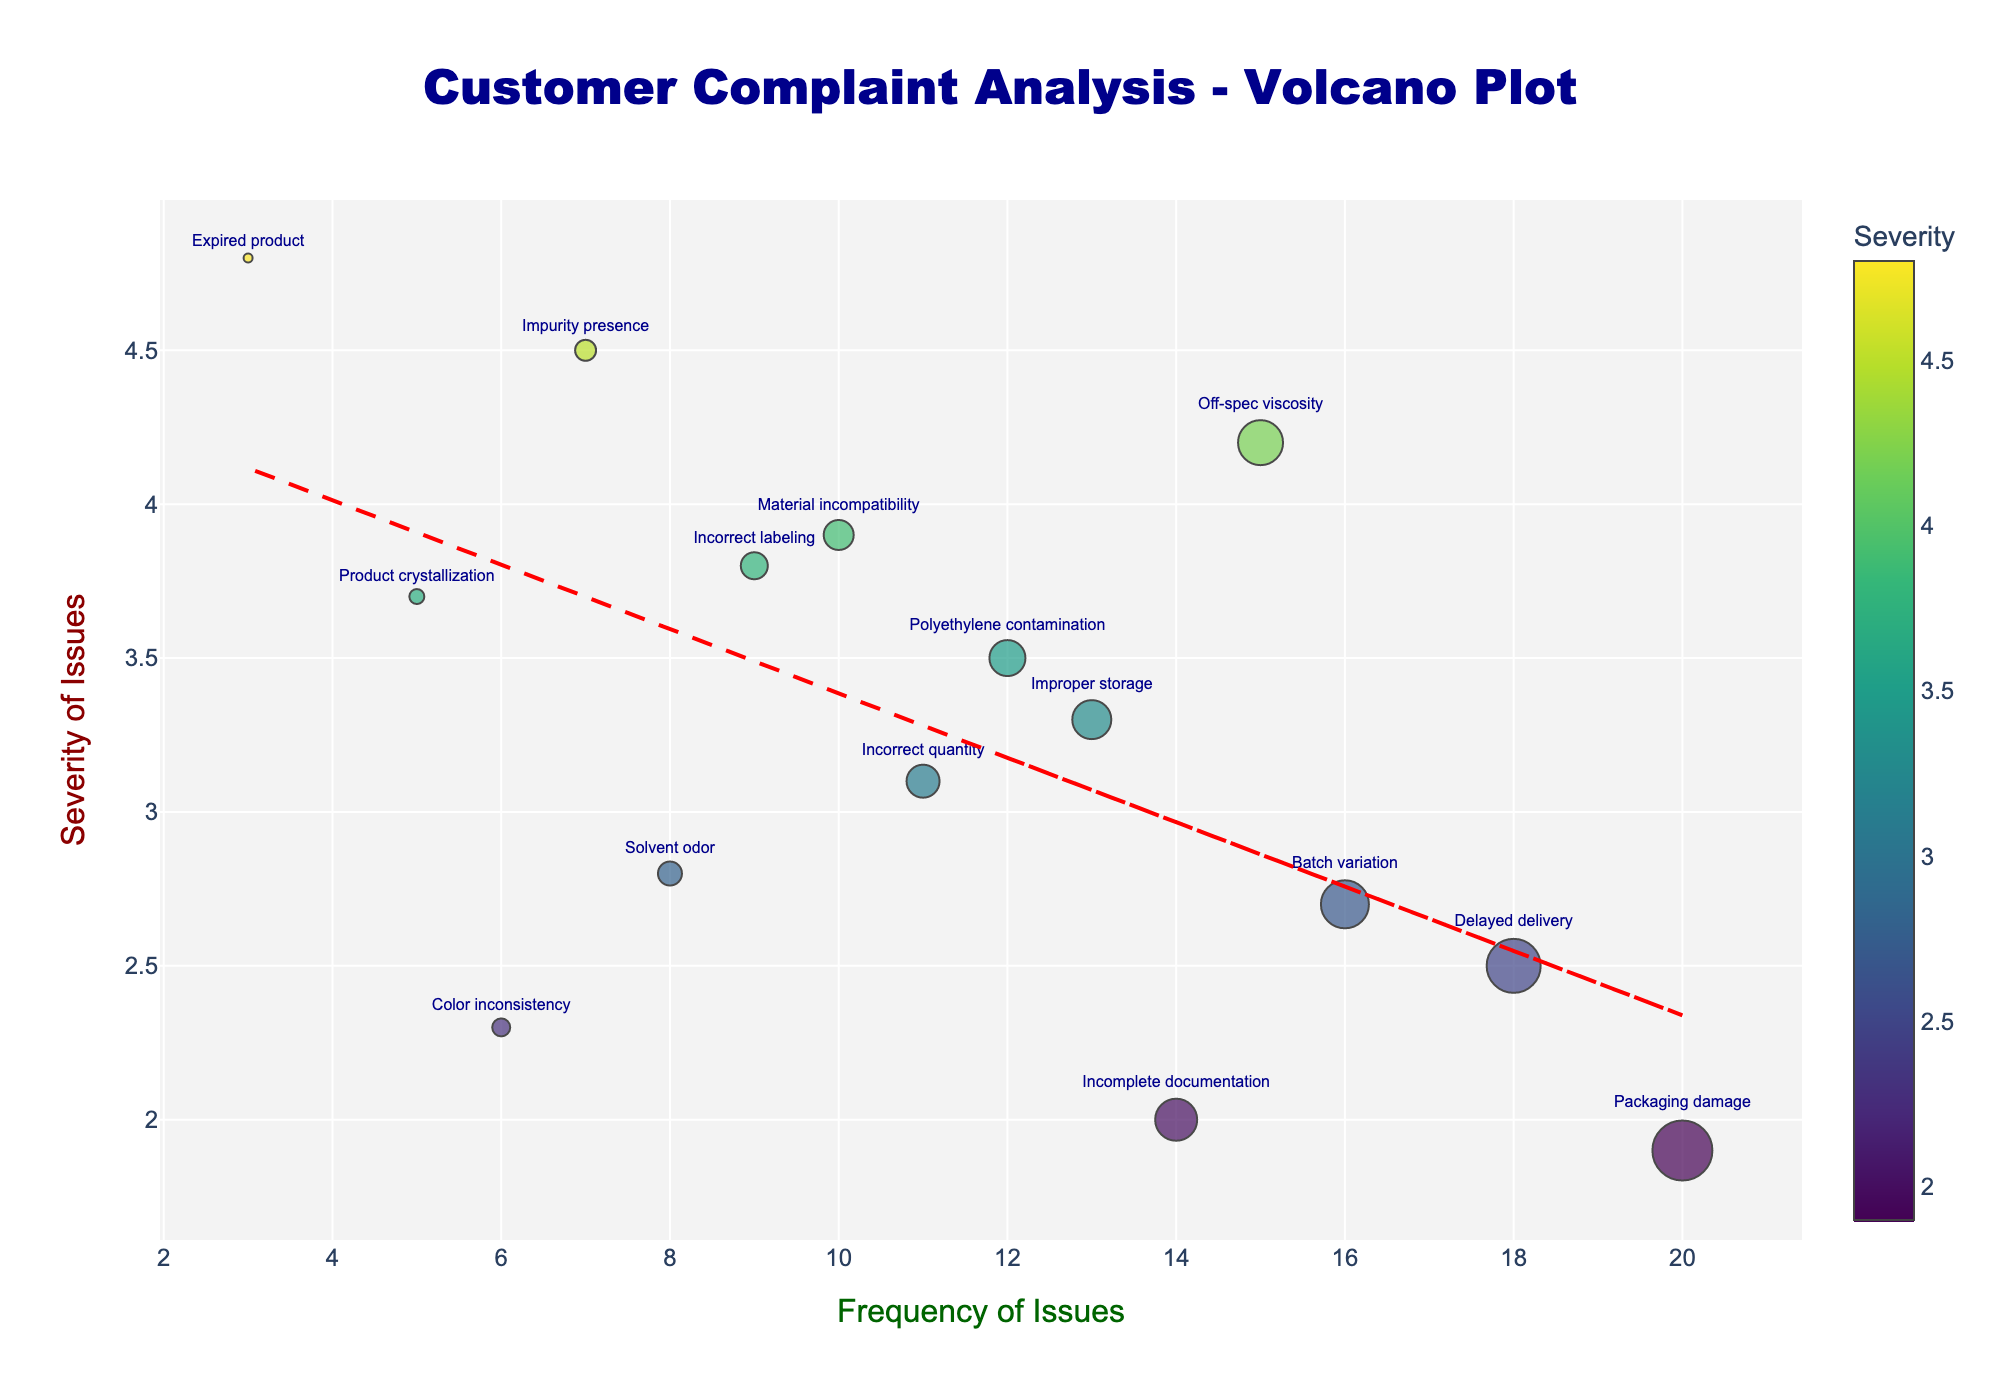How many data points represent customer complaints in the figure? Count the number of markers on the plot. Each marker represents a data point corresponding to a product complaint.
Answer: 15 Which complaint has the highest frequency? Locate the marker farthest to the right on the x-axis. The x-axis represents frequency, so the marker farthest right has the highest frequency.
Answer: Packaging damage Which complaint has the highest severity? Locate the marker highest on the y-axis. The y-axis represents severity, so the marker highest up has the highest severity.
Answer: Expired product What is the general trend shown by the red dashed line? Identify the orientation of the trend line. A red dashed line sloping upwards suggests that as the frequency of complaints increases, the severity of complaints also tends to increase.
Answer: Positive correlation What are the combined frequencies of 'Off-spec viscosity' and 'Batch variation'? Identify the frequency values for both 'Off-spec viscosity' and 'Batch variation' from the plot and add them together. Off-spec viscosity: 15, Batch Variation: 16, so 15 + 16 = 31.
Answer: 31 Which complaint has greater severity: 'Polyethylene contamination' or 'Delayed delivery'? Compare the y-axis positions of the 'Polyethylene contamination' and 'Delayed delivery' markers. The one higher up has greater severity.
Answer: Polyethylene contamination Identify the least frequent and least severe complaint. Locate the marker closest to the origin (lowest x and y values) on the plot.
Answer: Expired product Which complaint is both frequent and has high severity? Look for the marker in the upper-right quadrant that is far along both x and y axes (frequency and severity).
Answer: Off-spec viscosity How many complaints have a severity greater than 3.5? Count the number of markers positioned above the 3.5 line on the y-axis.
Answer: 7 Between 'Solvent odor' and 'Incorrect quantity', which has a higher frequency and by how much? Identify the x-axis positions for both 'Solvent odor' and 'Incorrect quantity'. Solvent odor has a frequency of 8, Incorrect quantity has a frequency of 11, so the difference is 11 - 8 = 3.
Answer: Incorrect quantity by 3 